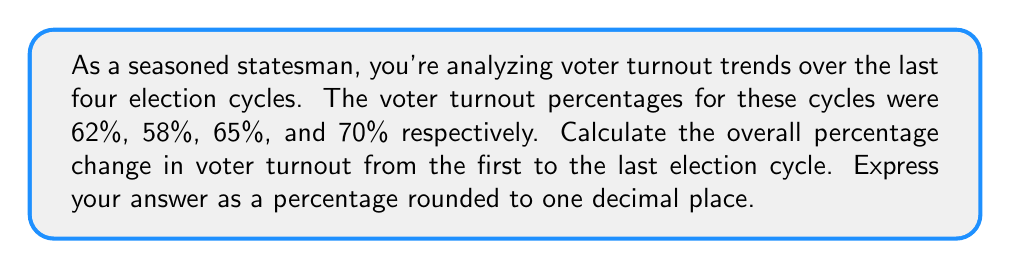Could you help me with this problem? To calculate the overall percentage change in voter turnout, we need to follow these steps:

1) Identify the initial value (first election cycle turnout) and final value (last election cycle turnout):
   Initial value: $62\%$
   Final value: $70\%$

2) Calculate the change in value:
   $\text{Change} = \text{Final value} - \text{Initial value}$
   $\text{Change} = 70\% - 62\% = 8\%$

3) Calculate the percentage change using the formula:
   $$\text{Percentage change} = \frac{\text{Change}}{\text{Initial value}} \times 100\%$$

4) Substitute the values:
   $$\text{Percentage change} = \frac{8\%}{62\%} \times 100\%$$

5) Perform the calculation:
   $$\text{Percentage change} = 0.129032 \times 100\% = 12.9032\%$$

6) Round to one decimal place:
   $12.9\%$

Therefore, the overall percentage change in voter turnout from the first to the last election cycle is 12.9%.
Answer: 12.9% 